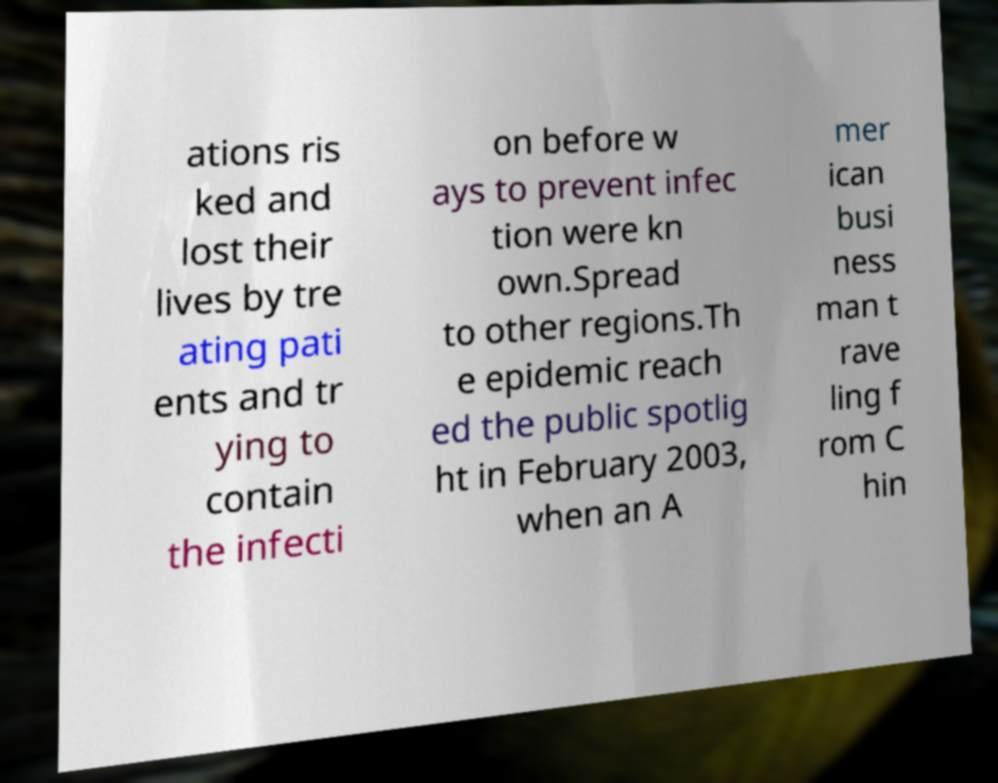Can you read and provide the text displayed in the image?This photo seems to have some interesting text. Can you extract and type it out for me? ations ris ked and lost their lives by tre ating pati ents and tr ying to contain the infecti on before w ays to prevent infec tion were kn own.Spread to other regions.Th e epidemic reach ed the public spotlig ht in February 2003, when an A mer ican busi ness man t rave ling f rom C hin 